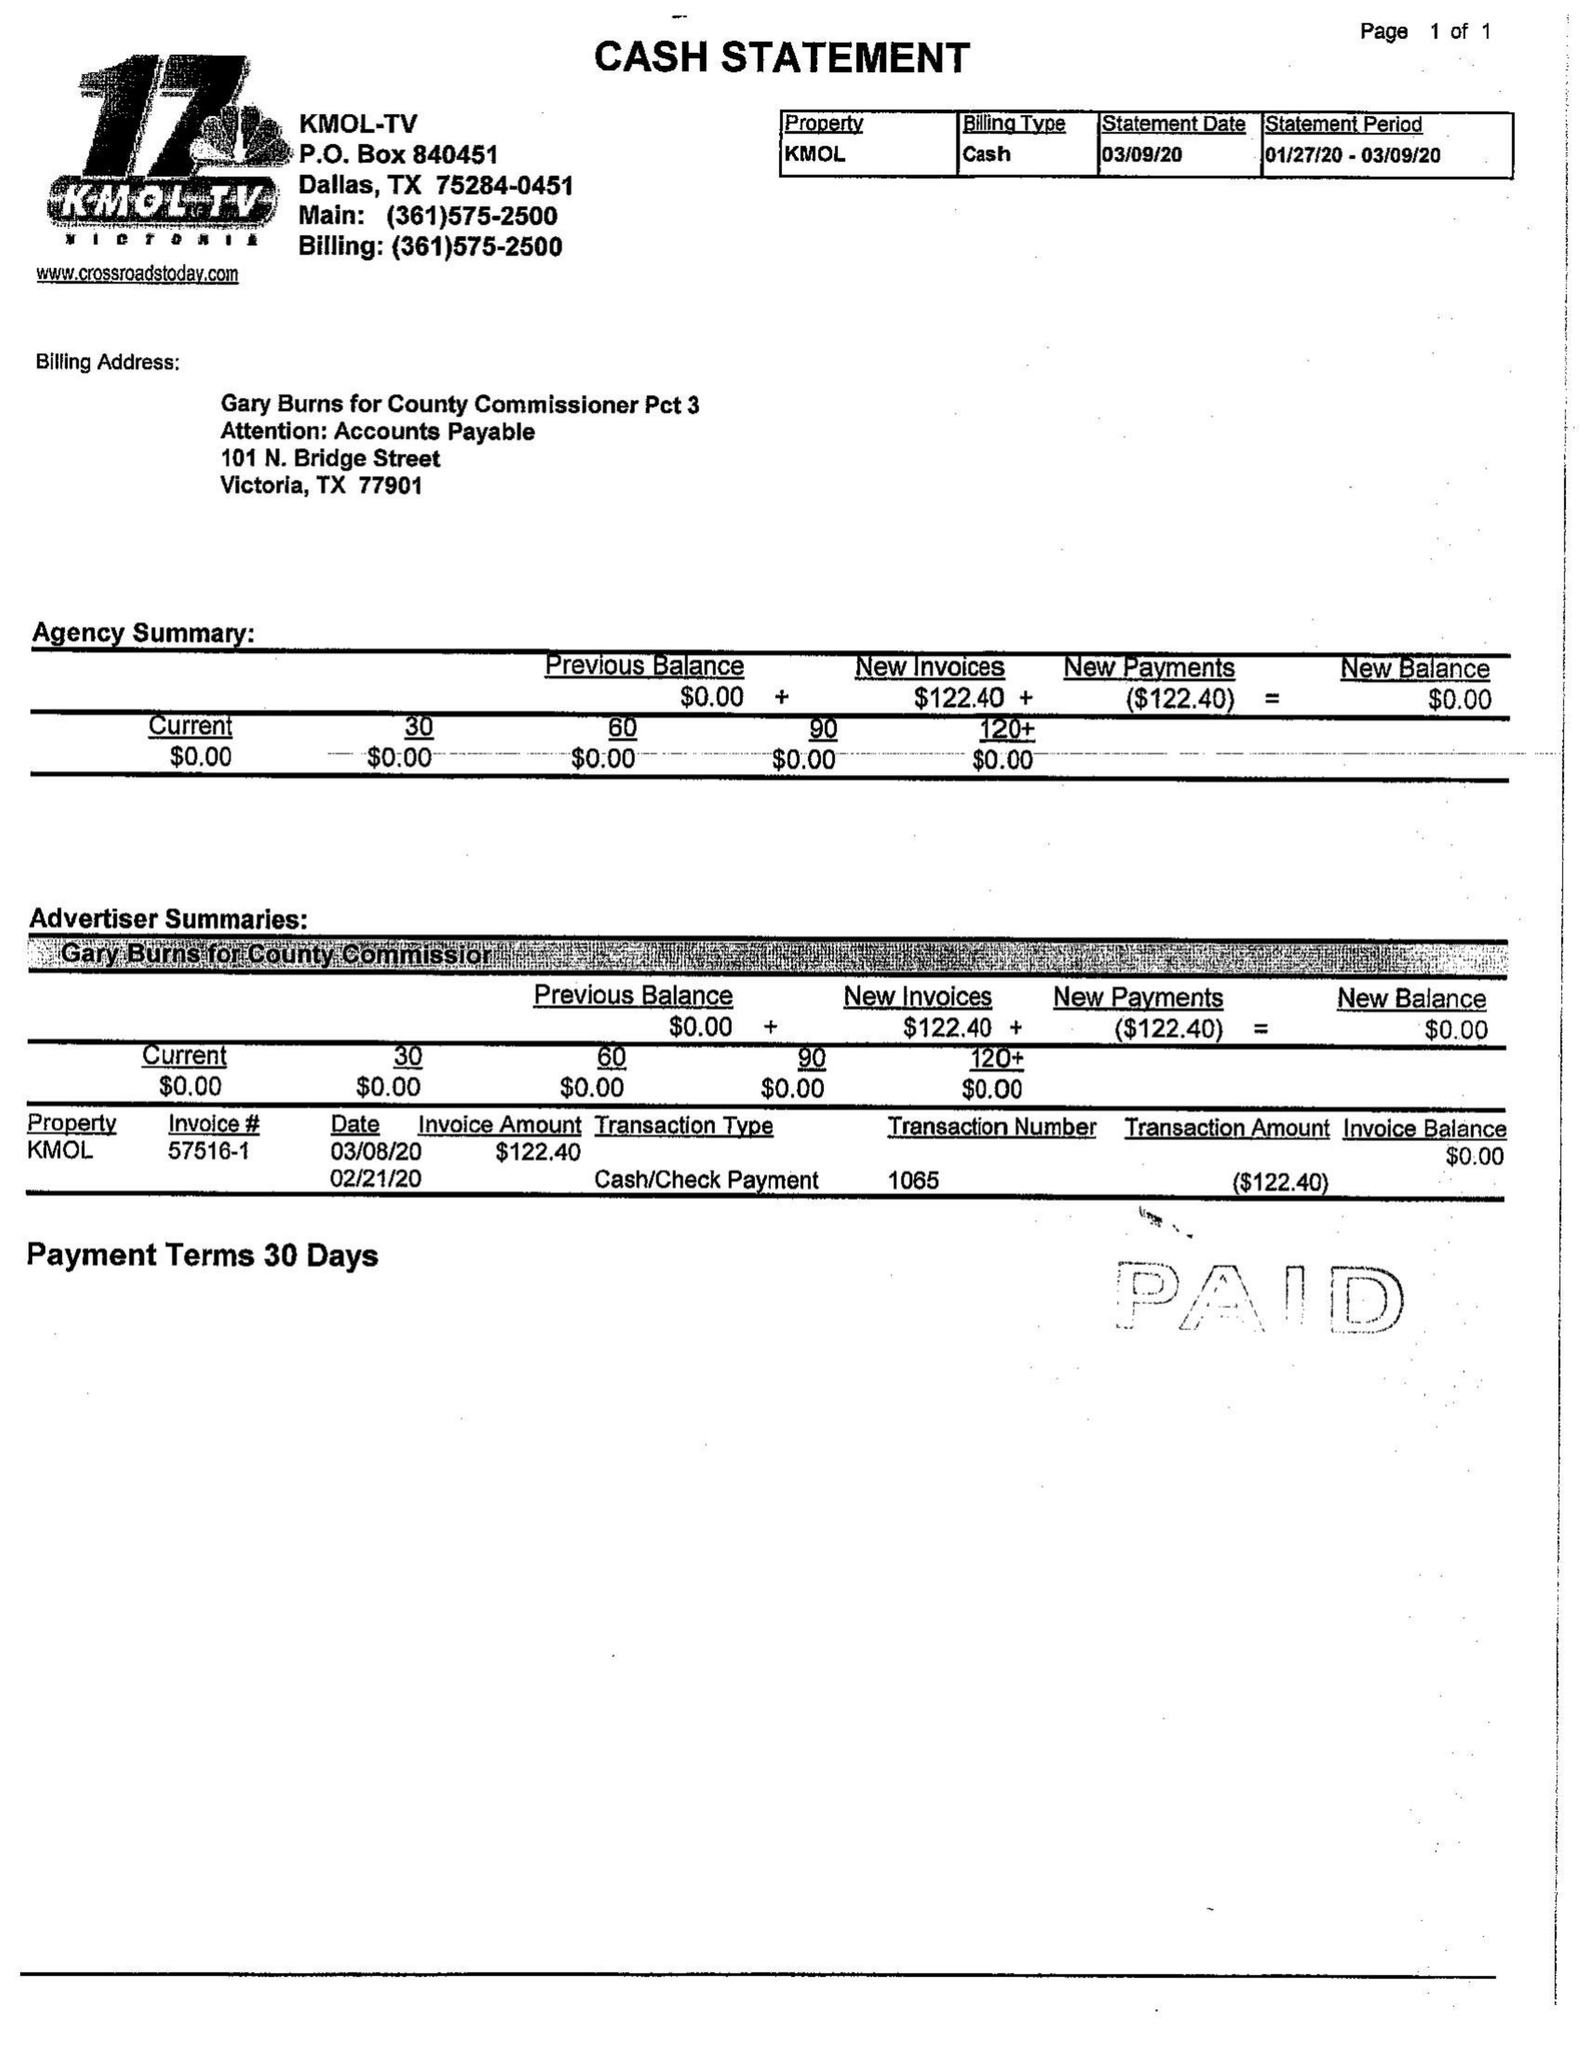What is the value for the advertiser?
Answer the question using a single word or phrase. GARY BURNS FOR COUNTY COMMISSIONER 